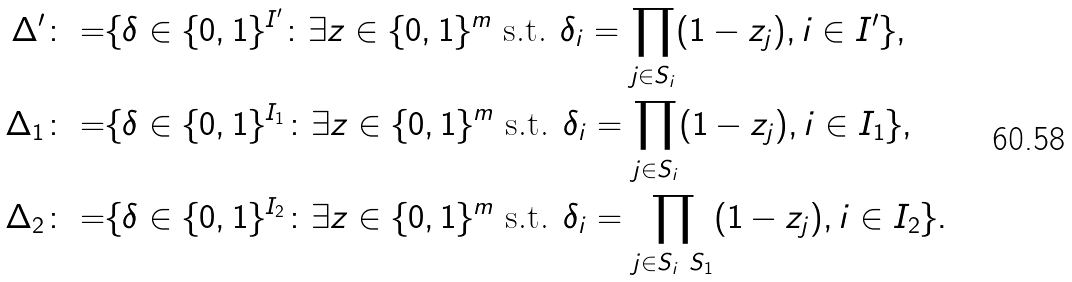<formula> <loc_0><loc_0><loc_500><loc_500>\Delta ^ { \prime } \colon = & \{ \delta \in \{ 0 , 1 \} ^ { I ^ { \prime } } \colon \exists z \in \{ 0 , 1 \} ^ { m } \text { s.t. } \delta _ { i } = \prod _ { j \in S _ { i } } ( 1 - z _ { j } ) , i \in I ^ { \prime } \} , \\ \Delta _ { 1 } \colon = & \{ \delta \in \{ 0 , 1 \} ^ { I _ { 1 } } \colon \exists z \in \{ 0 , 1 \} ^ { m } \text { s.t. } \delta _ { i } = \prod _ { j \in S _ { i } } ( 1 - z _ { j } ) , i \in I _ { 1 } \} , \\ \Delta _ { 2 } \colon = & \{ \delta \in \{ 0 , 1 \} ^ { I _ { 2 } } \colon \exists z \in \{ 0 , 1 \} ^ { m } \text { s.t. } \delta _ { i } = \prod _ { j \in S _ { i } \ S _ { 1 } } ( 1 - z _ { j } ) , i \in I _ { 2 } \} .</formula> 